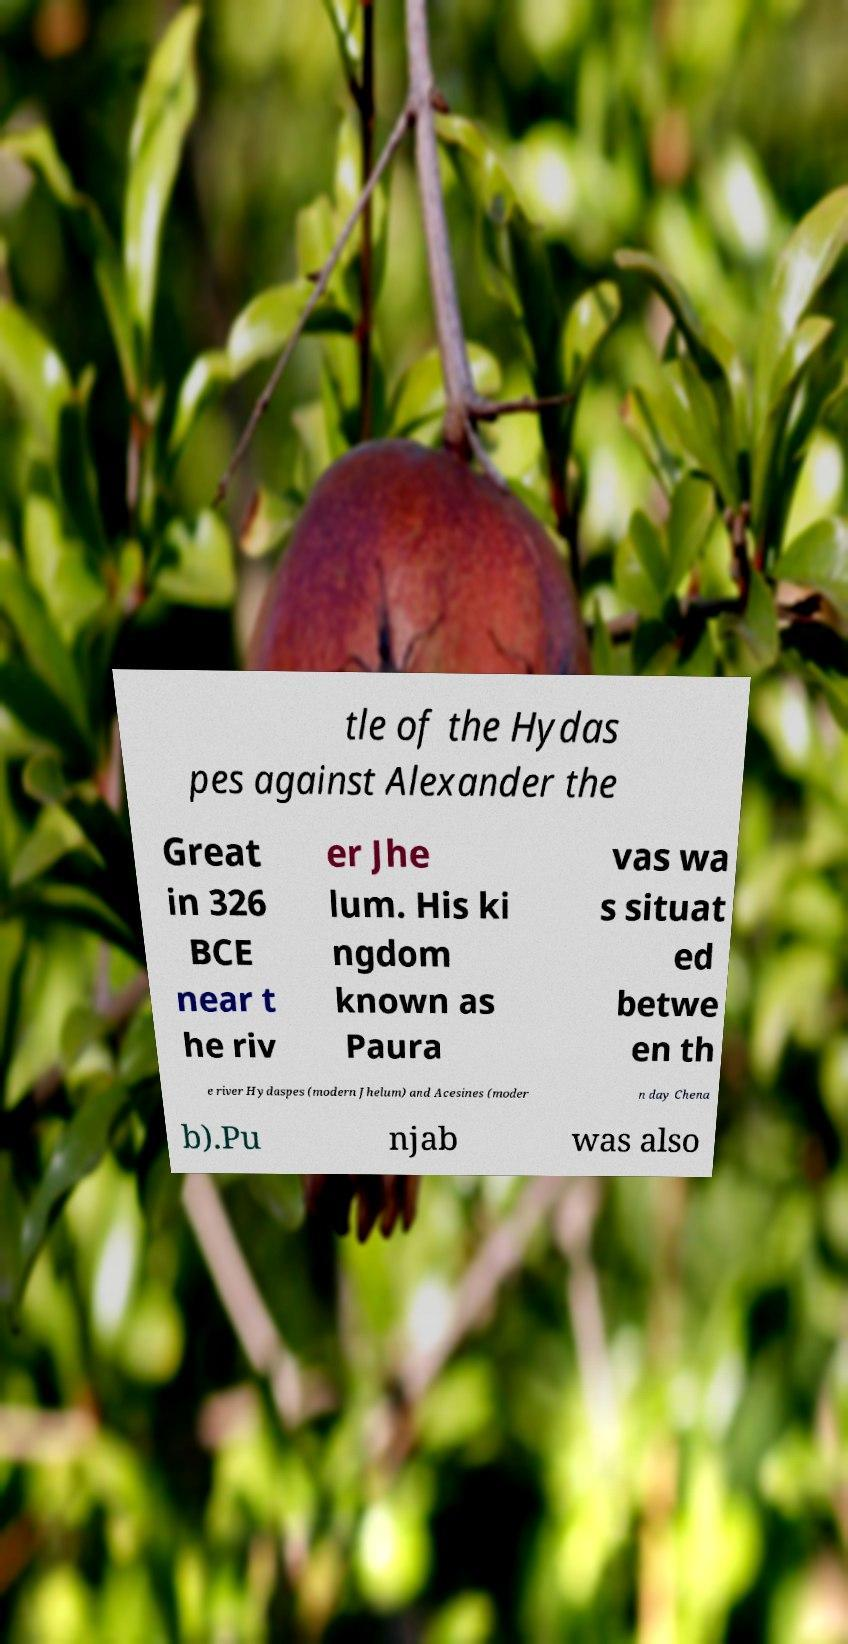For documentation purposes, I need the text within this image transcribed. Could you provide that? tle of the Hydas pes against Alexander the Great in 326 BCE near t he riv er Jhe lum. His ki ngdom known as Paura vas wa s situat ed betwe en th e river Hydaspes (modern Jhelum) and Acesines (moder n day Chena b).Pu njab was also 